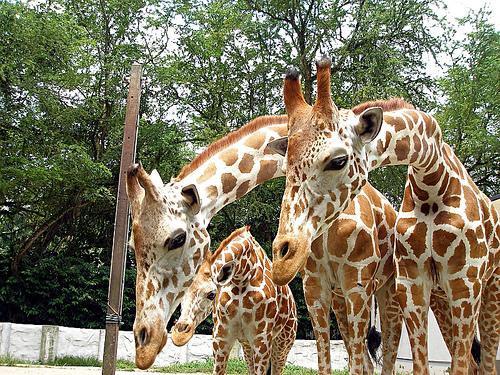How many ears can you see?
Give a very brief answer. 4. Where are these animals from?
Concise answer only. Africa. Which direction are the animals looking in?
Write a very short answer. Down. 